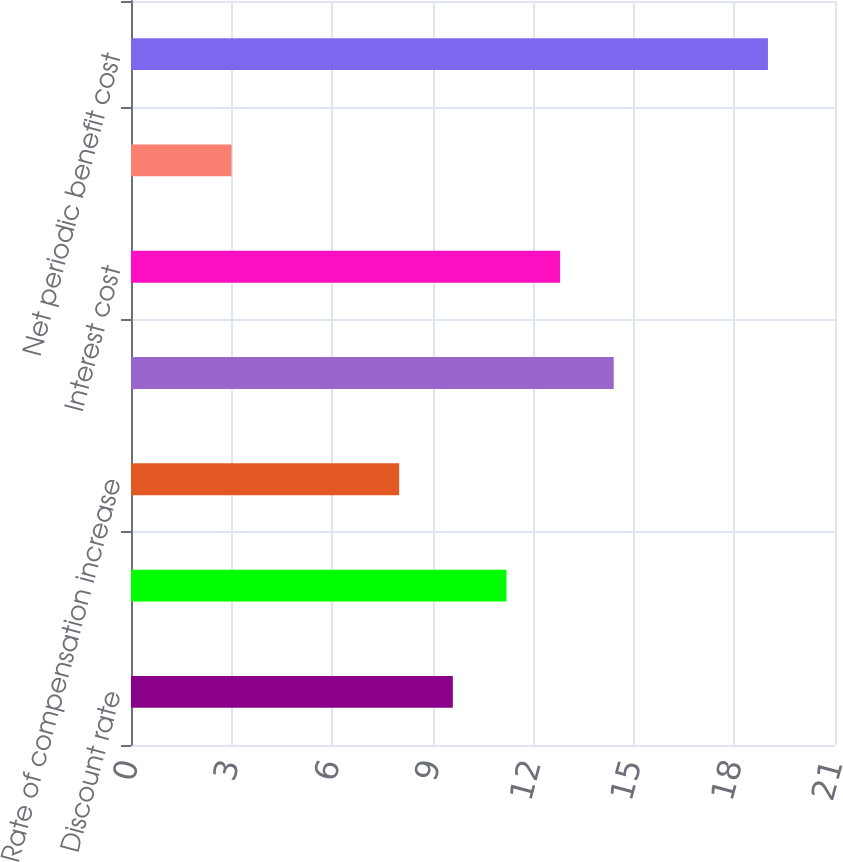<chart> <loc_0><loc_0><loc_500><loc_500><bar_chart><fcel>Discount rate<fcel>Expected return on plan assets<fcel>Rate of compensation increase<fcel>Service cost<fcel>Interest cost<fcel>Amortization of net actuarial<fcel>Net periodic benefit cost<nl><fcel>9.6<fcel>11.2<fcel>8<fcel>14.4<fcel>12.8<fcel>3<fcel>19<nl></chart> 